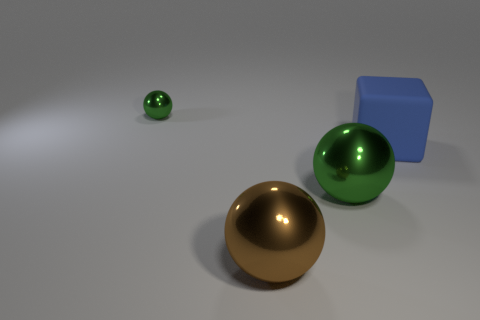Add 2 small things. How many objects exist? 6 Subtract all cubes. How many objects are left? 3 Add 3 blue cubes. How many blue cubes exist? 4 Subtract 0 red balls. How many objects are left? 4 Subtract all big matte things. Subtract all large green metal things. How many objects are left? 2 Add 2 brown shiny things. How many brown shiny things are left? 3 